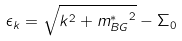Convert formula to latex. <formula><loc_0><loc_0><loc_500><loc_500>\epsilon _ { k } = \sqrt { k ^ { 2 } + { m _ { B G } ^ { * } } ^ { 2 } } - \Sigma _ { 0 }</formula> 